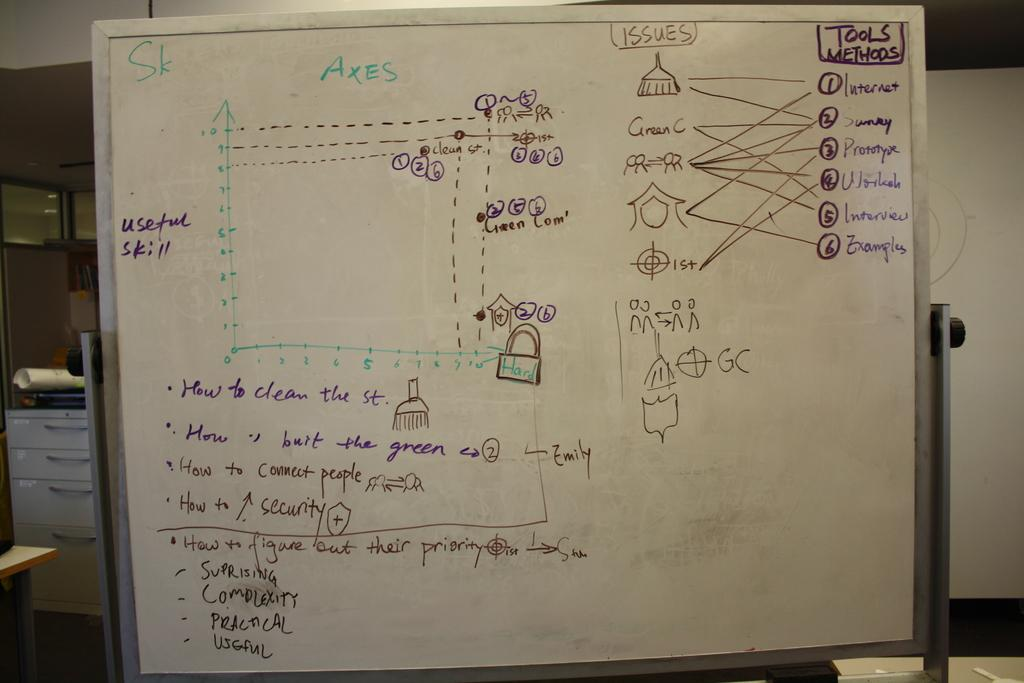Provide a one-sentence caption for the provided image. White board showing a diagram about issues and methods. 